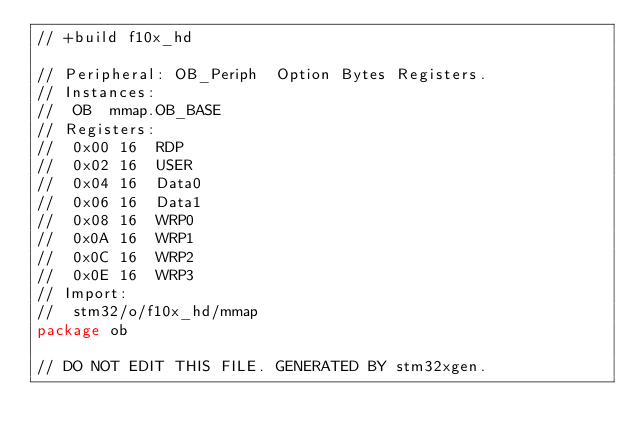Convert code to text. <code><loc_0><loc_0><loc_500><loc_500><_Go_>// +build f10x_hd

// Peripheral: OB_Periph  Option Bytes Registers.
// Instances:
//  OB  mmap.OB_BASE
// Registers:
//  0x00 16  RDP
//  0x02 16  USER
//  0x04 16  Data0
//  0x06 16  Data1
//  0x08 16  WRP0
//  0x0A 16  WRP1
//  0x0C 16  WRP2
//  0x0E 16  WRP3
// Import:
//  stm32/o/f10x_hd/mmap
package ob

// DO NOT EDIT THIS FILE. GENERATED BY stm32xgen.
</code> 